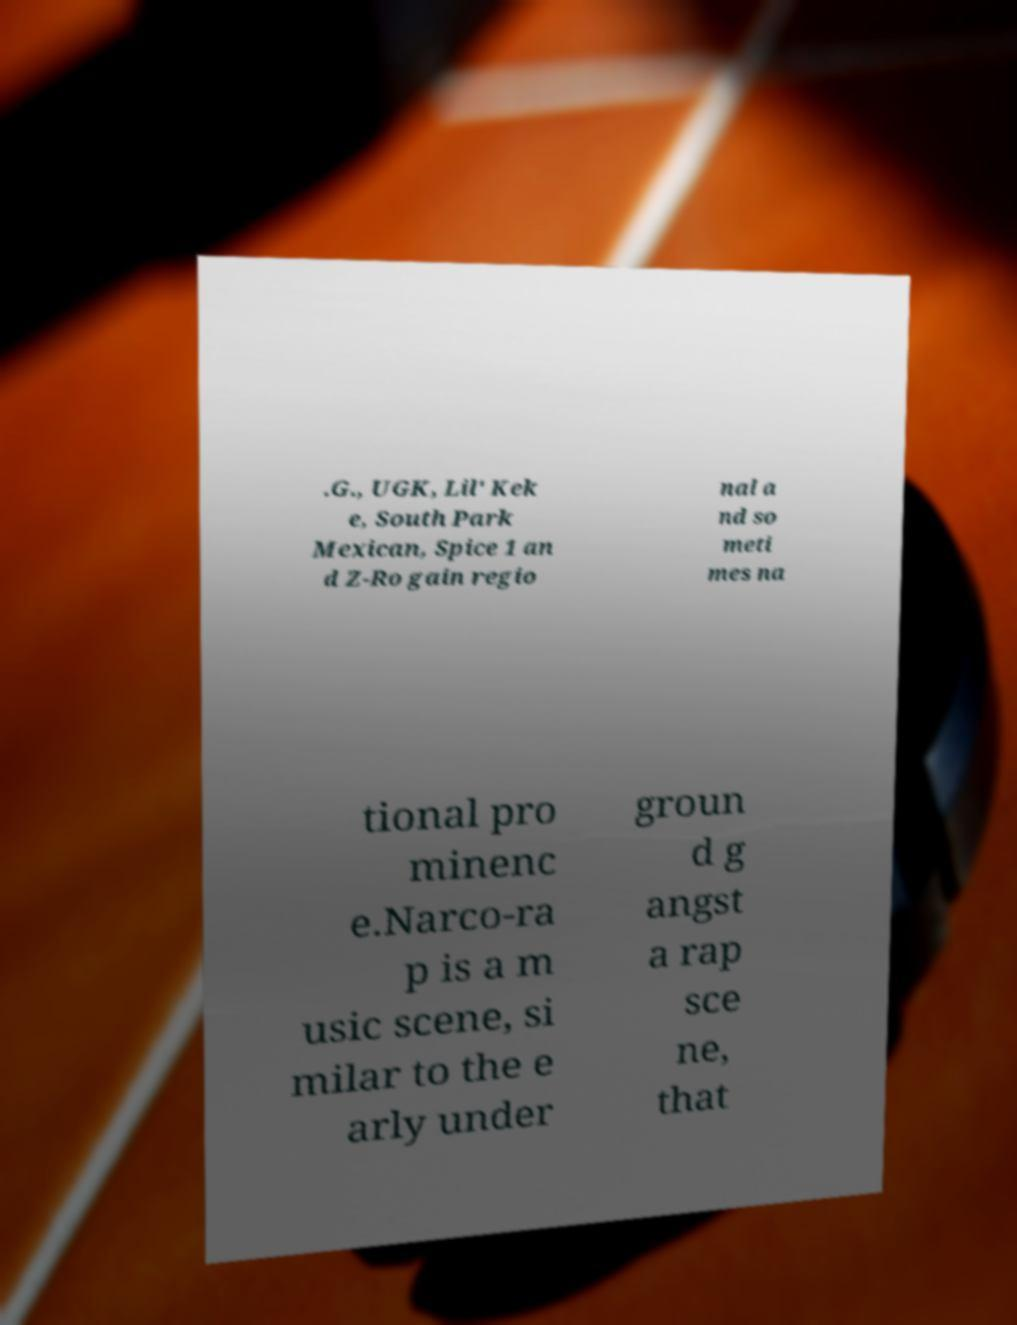For documentation purposes, I need the text within this image transcribed. Could you provide that? .G., UGK, Lil' Kek e, South Park Mexican, Spice 1 an d Z-Ro gain regio nal a nd so meti mes na tional pro minenc e.Narco-ra p is a m usic scene, si milar to the e arly under groun d g angst a rap sce ne, that 